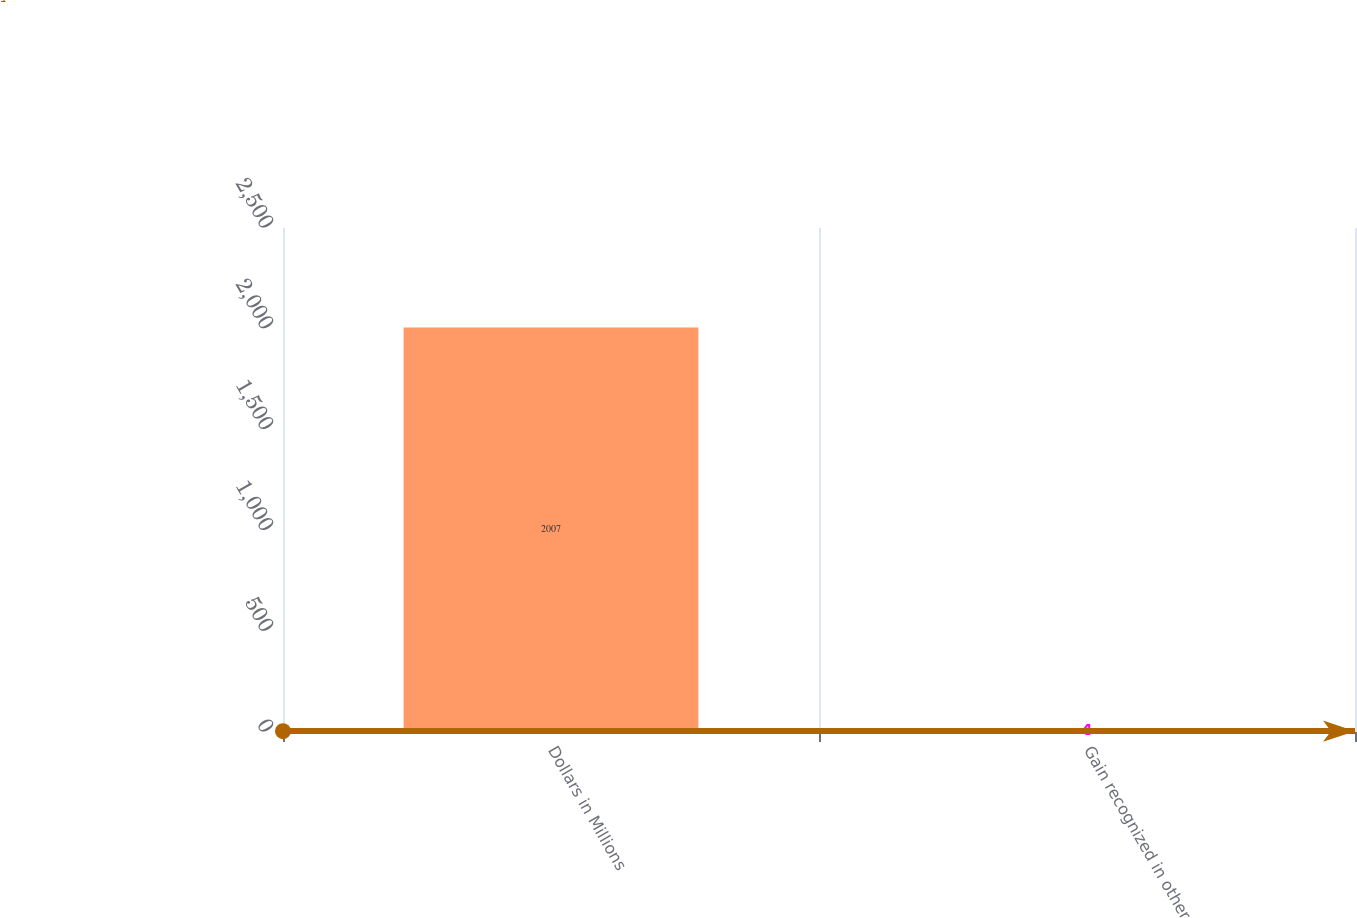<chart> <loc_0><loc_0><loc_500><loc_500><bar_chart><fcel>Dollars in Millions<fcel>Gain recognized in other<nl><fcel>2007<fcel>4<nl></chart> 